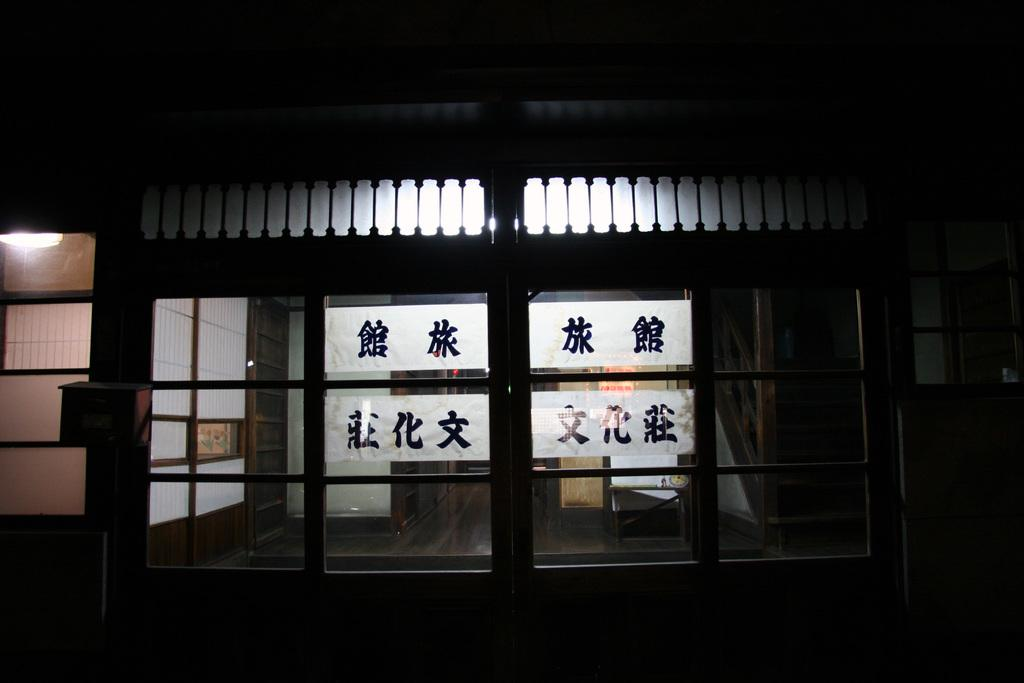What is the overall appearance of the image? The image is completely dark. Is there any source of light in the image? Yes, there is a light in the top left corner of the image. What type of architectural feature can be seen in the image? There are glass doors in the image. What type of plough is being used to cultivate the field in the image? There is no field or plough present in the image; it is completely dark with a light in the top left corner and glass doors. What kind of board is being used to play a game in the image? There is no board or game present in the image; it is completely dark with a light in the top left corner and glass doors. 